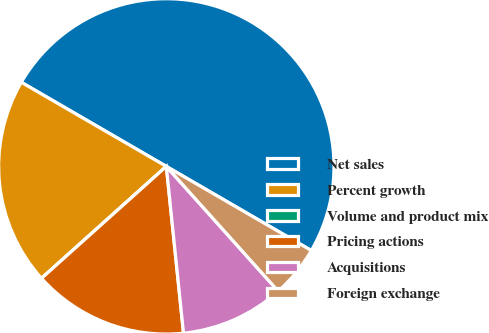Convert chart. <chart><loc_0><loc_0><loc_500><loc_500><pie_chart><fcel>Net sales<fcel>Percent growth<fcel>Volume and product mix<fcel>Pricing actions<fcel>Acquisitions<fcel>Foreign exchange<nl><fcel>50.0%<fcel>20.0%<fcel>0.0%<fcel>15.0%<fcel>10.0%<fcel>5.0%<nl></chart> 